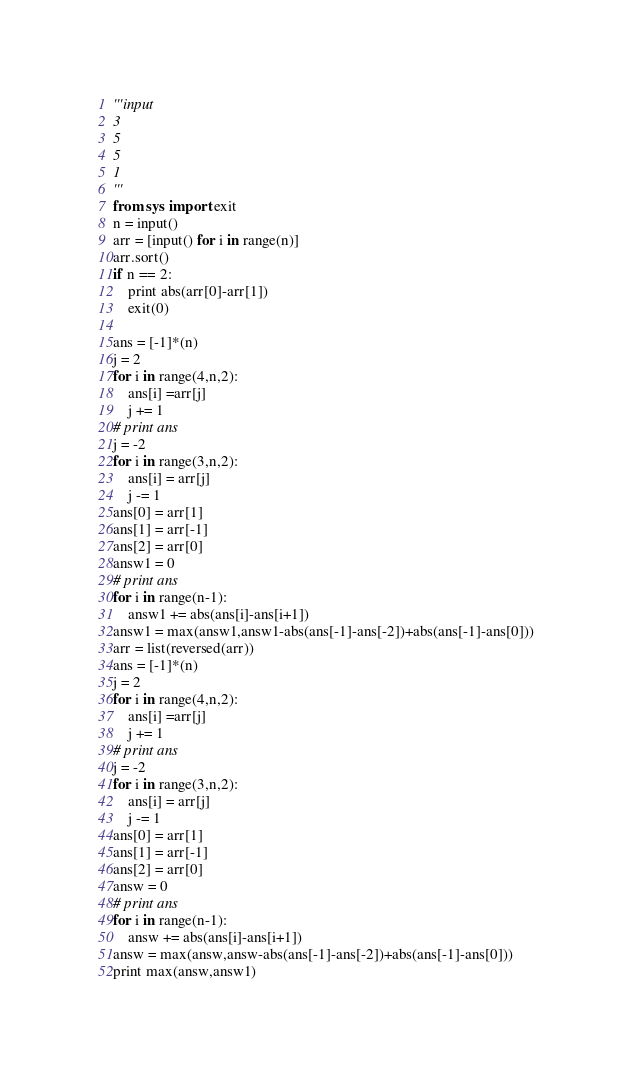<code> <loc_0><loc_0><loc_500><loc_500><_Python_>'''input
3
5
5
1
'''
from sys import exit
n = input()
arr = [input() for i in range(n)]
arr.sort()
if n == 2:
	print abs(arr[0]-arr[1])
	exit(0)

ans = [-1]*(n)
j = 2
for i in range(4,n,2):
	ans[i] =arr[j]
	j += 1
# print ans
j = -2
for i in range(3,n,2):
	ans[i] = arr[j]
	j -= 1
ans[0] = arr[1]
ans[1] = arr[-1]
ans[2] = arr[0]
answ1 = 0
# print ans
for i in range(n-1):
	answ1 += abs(ans[i]-ans[i+1])
answ1 = max(answ1,answ1-abs(ans[-1]-ans[-2])+abs(ans[-1]-ans[0]))
arr = list(reversed(arr))
ans = [-1]*(n)
j = 2
for i in range(4,n,2):
	ans[i] =arr[j]
	j += 1
# print ans
j = -2
for i in range(3,n,2):
	ans[i] = arr[j]
	j -= 1
ans[0] = arr[1]
ans[1] = arr[-1]
ans[2] = arr[0]
answ = 0
# print ans
for i in range(n-1):
	answ += abs(ans[i]-ans[i+1])
answ = max(answ,answ-abs(ans[-1]-ans[-2])+abs(ans[-1]-ans[0]))
print max(answ,answ1)
</code> 